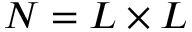Convert formula to latex. <formula><loc_0><loc_0><loc_500><loc_500>N = L \times L</formula> 